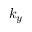<formula> <loc_0><loc_0><loc_500><loc_500>k _ { y }</formula> 